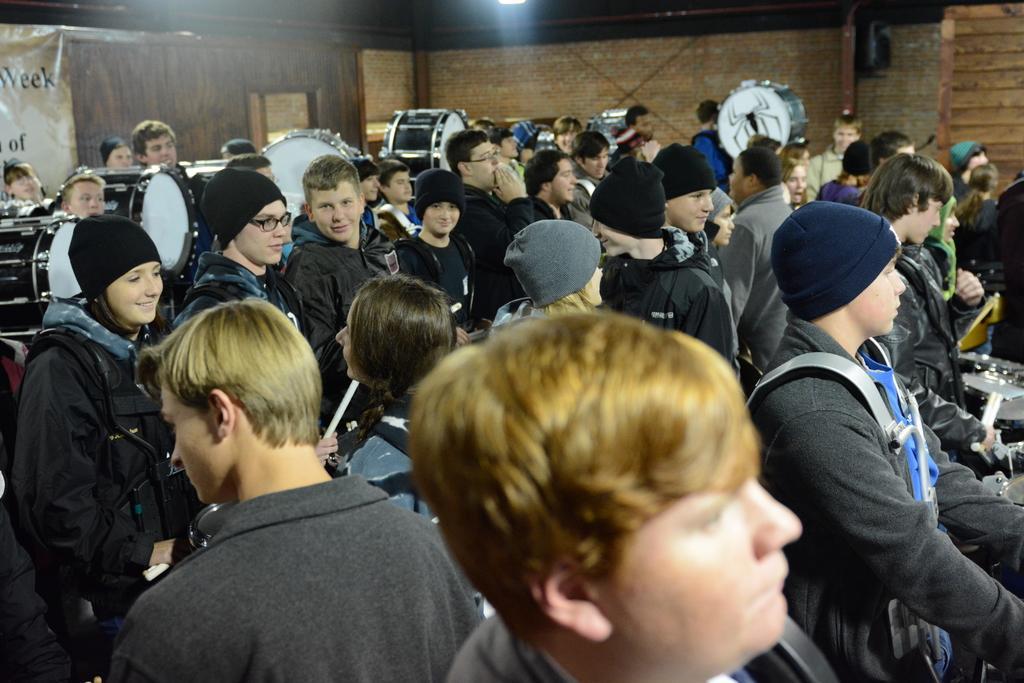Could you give a brief overview of what you see in this image? In this image I can see group of children playing with musical instruments and there is a wall in the background with brown color. And also in the top right corner there is a drum and there is a spider sticker on the front side of the drum 